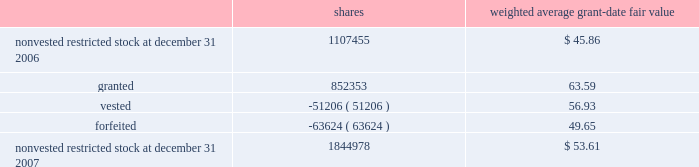Humana inc .
Notes to consolidated financial statements 2014 ( continued ) the total intrinsic value of stock options exercised during 2007 was $ 133.9 million , compared with $ 133.7 million during 2006 and $ 57.8 million during 2005 .
Cash received from stock option exercises for the years ended december 31 , 2007 , 2006 , and 2005 totaled $ 62.7 million , $ 49.2 million , and $ 36.4 million , respectively .
Total compensation expense related to nonvested options not yet recognized was $ 23.6 million at december 31 , 2007 .
We expect to recognize this compensation expense over a weighted average period of approximately 1.6 years .
Restricted stock awards restricted stock awards are granted with a fair value equal to the market price of our common stock on the date of grant .
Compensation expense is recorded straight-line over the vesting period , generally three years from the date of grant .
The weighted average grant date fair value of our restricted stock awards was $ 63.59 , $ 54.36 , and $ 32.81 for the years ended december 31 , 2007 , 2006 , and 2005 , respectively .
Activity for our restricted stock awards was as follows for the year ended december 31 , 2007 : shares weighted average grant-date fair value .
The fair value of shares vested during the years ended december 31 , 2007 , 2006 , and 2005 was $ 3.4 million , $ 2.3 million , and $ 0.6 million , respectively .
Total compensation expense related to nonvested restricted stock awards not yet recognized was $ 44.7 million at december 31 , 2007 .
We expect to recognize this compensation expense over a weighted average period of approximately 1.4 years .
There are no other contractual terms covering restricted stock awards once vested. .
Considering the years 2005-2007 , what is the average fair value of shares vested , in millions? 
Rationale: it is the sum of all values divided by three .
Computations: (((3.4 + 0.6) + 2.3) / 3)
Answer: 2.1. 